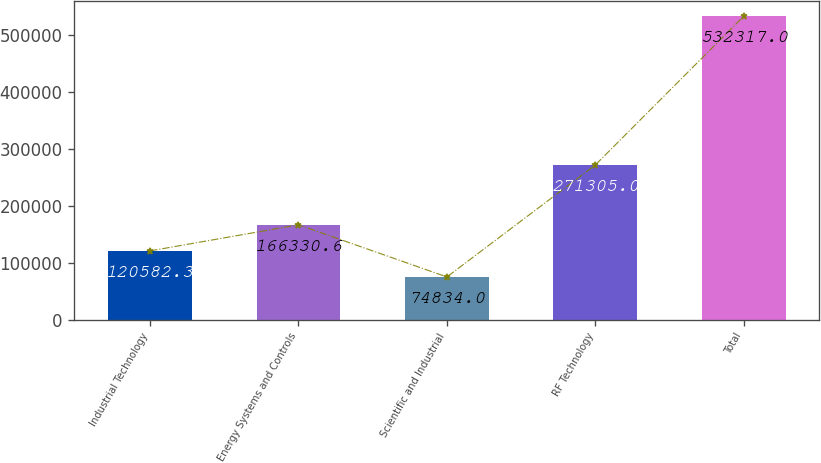Convert chart. <chart><loc_0><loc_0><loc_500><loc_500><bar_chart><fcel>Industrial Technology<fcel>Energy Systems and Controls<fcel>Scientific and Industrial<fcel>RF Technology<fcel>Total<nl><fcel>120582<fcel>166331<fcel>74834<fcel>271305<fcel>532317<nl></chart> 